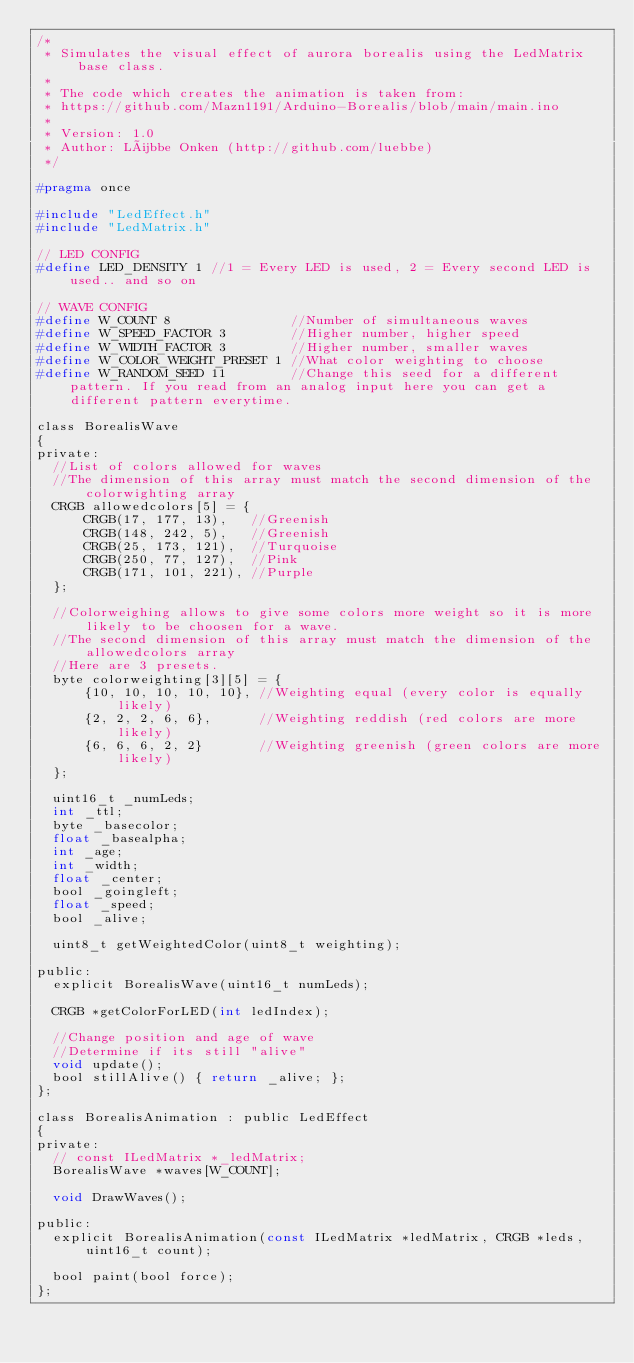<code> <loc_0><loc_0><loc_500><loc_500><_C_>/*
 * Simulates the visual effect of aurora borealis using the LedMatrix base class.
 * 
 * The code which creates the animation is taken from:
 * https://github.com/Mazn1191/Arduino-Borealis/blob/main/main.ino
 *
 * Version: 1.0
 * Author: Lübbe Onken (http://github.com/luebbe)
 */

#pragma once

#include "LedEffect.h"
#include "LedMatrix.h"

// LED CONFIG
#define LED_DENSITY 1 //1 = Every LED is used, 2 = Every second LED is used.. and so on

// WAVE CONFIG
#define W_COUNT 8               //Number of simultaneous waves
#define W_SPEED_FACTOR 3        //Higher number, higher speed
#define W_WIDTH_FACTOR 3        //Higher number, smaller waves
#define W_COLOR_WEIGHT_PRESET 1 //What color weighting to choose
#define W_RANDOM_SEED 11        //Change this seed for a different pattern. If you read from an analog input here you can get a different pattern everytime.

class BorealisWave
{
private:
  //List of colors allowed for waves
  //The dimension of this array must match the second dimension of the colorwighting array
  CRGB allowedcolors[5] = {
      CRGB(17, 177, 13),   //Greenish
      CRGB(148, 242, 5),   //Greenish
      CRGB(25, 173, 121),  //Turquoise
      CRGB(250, 77, 127),  //Pink
      CRGB(171, 101, 221), //Purple
  };

  //Colorweighing allows to give some colors more weight so it is more likely to be choosen for a wave.
  //The second dimension of this array must match the dimension of the allowedcolors array
  //Here are 3 presets.
  byte colorweighting[3][5] = {
      {10, 10, 10, 10, 10}, //Weighting equal (every color is equally likely)
      {2, 2, 2, 6, 6},      //Weighting reddish (red colors are more likely)
      {6, 6, 6, 2, 2}       //Weighting greenish (green colors are more likely)
  };

  uint16_t _numLeds;
  int _ttl;
  byte _basecolor;
  float _basealpha;
  int _age;
  int _width;
  float _center;
  bool _goingleft;
  float _speed;
  bool _alive;

  uint8_t getWeightedColor(uint8_t weighting);

public:
  explicit BorealisWave(uint16_t numLeds);

  CRGB *getColorForLED(int ledIndex);

  //Change position and age of wave
  //Determine if its still "alive"
  void update();
  bool stillAlive() { return _alive; };
};

class BorealisAnimation : public LedEffect
{
private:
  // const ILedMatrix *_ledMatrix;
  BorealisWave *waves[W_COUNT];

  void DrawWaves();

public:
  explicit BorealisAnimation(const ILedMatrix *ledMatrix, CRGB *leds, uint16_t count);

  bool paint(bool force);
};
</code> 